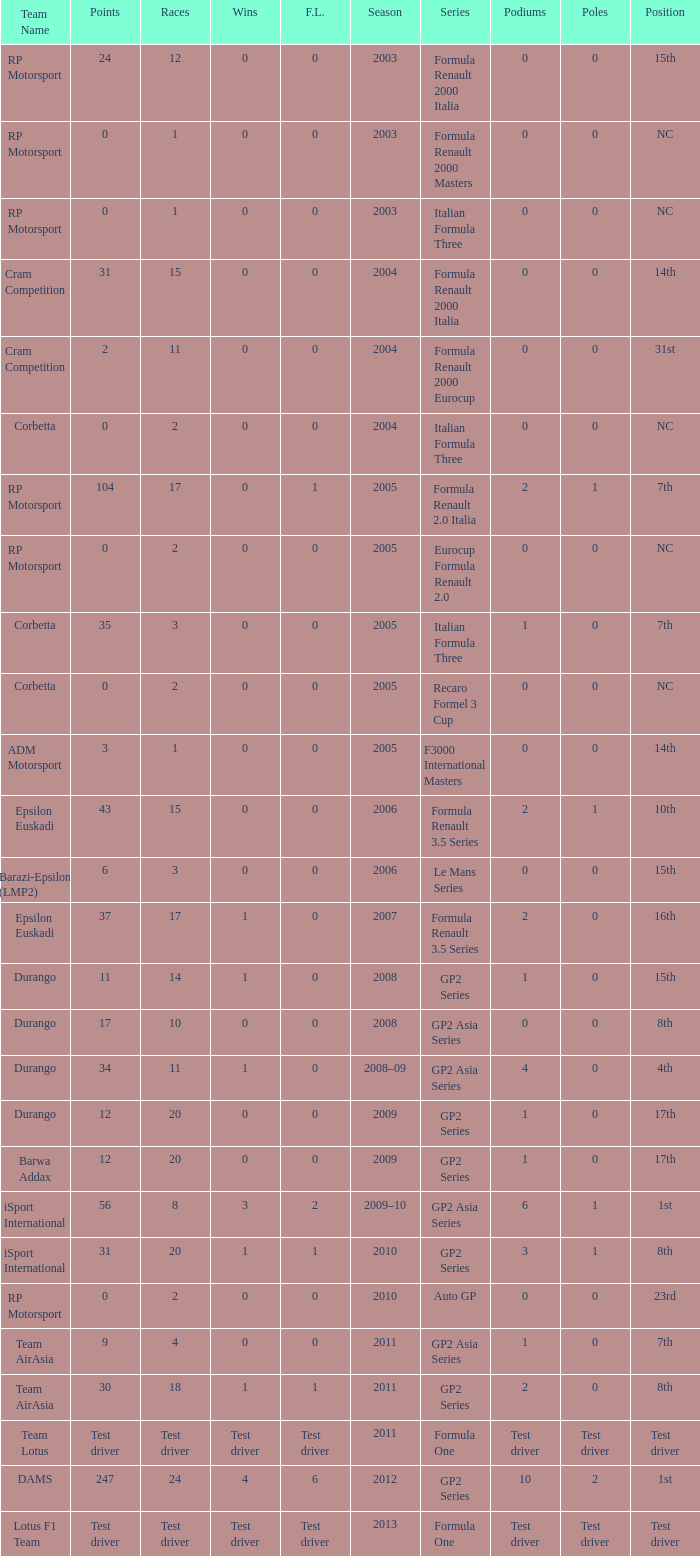What is the number of podiums with 0 wins and 6 points? 0.0. 